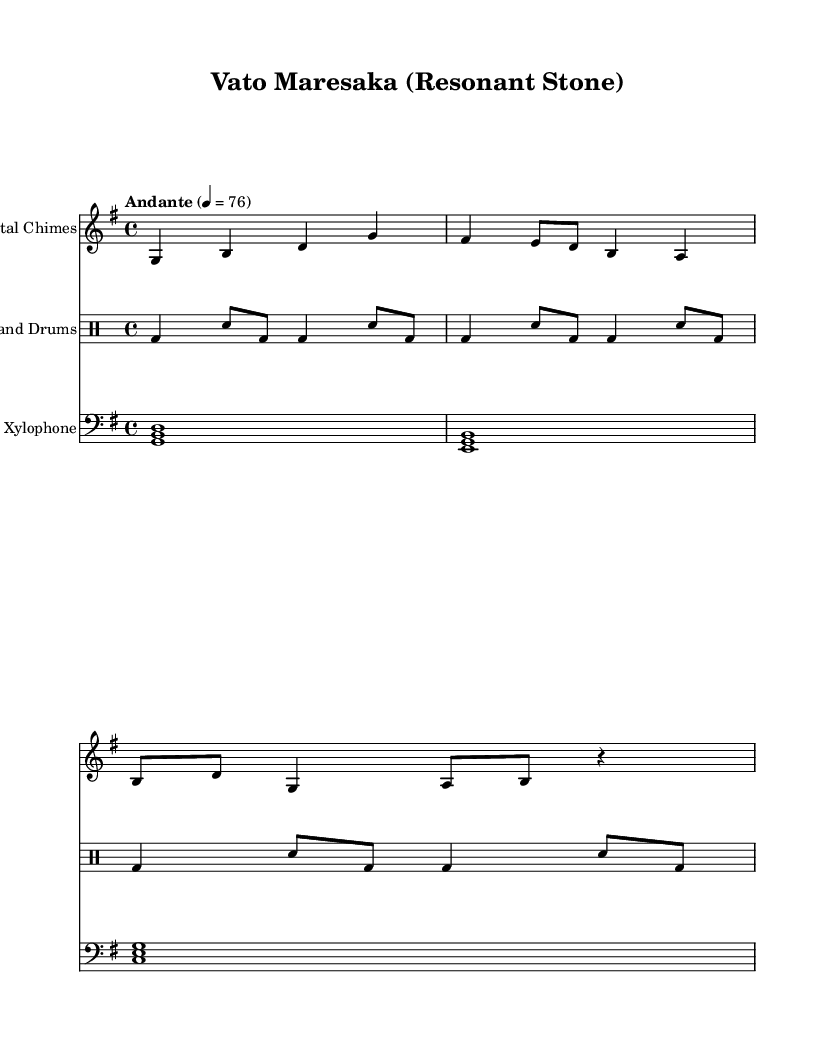What is the key signature of this music? The key signature is G major, which has one sharp (F#). The presence of the sharp indicates that the music is set in the G major scale.
Answer: G major What is the time signature of this piece? The time signature is 4/4, indicating that there are four beats in each measure, and a quarter note receives one beat. This is indicated at the beginning of the score.
Answer: 4/4 What is the tempo marking for the piece? The tempo marking "Andante" indicates a moderate pace, and the beats per minute marked as 76 tells us it is at a walking speed. This gives context to the music's intended flow and style.
Answer: Andante 4 = 76 Which instrument plays the melody? The "Quartz Crystal Chimes" play the melody, as indicated by the first staff in the score, where the notes are arranged melodically. This distinguishes it from the other instruments playing rhythm.
Answer: Quartz Crystal Chimes How many measures are there in the "Malachite Hand Drums" section? There are a total of six measures present in the "Malachite Hand Drums" section, as each grouping of notes separated by vertical lines represents a measure, and there are six such groupings.
Answer: 6 measures What type of instruments are featured in this score? The featured instruments are traditional ones made from native minerals of Madagascar: Quartz Crystal Chimes, Malachite Hand Drums, and Granite Stone Xylophone. Each is noted and categorized in the score.
Answer: Traditional instruments 